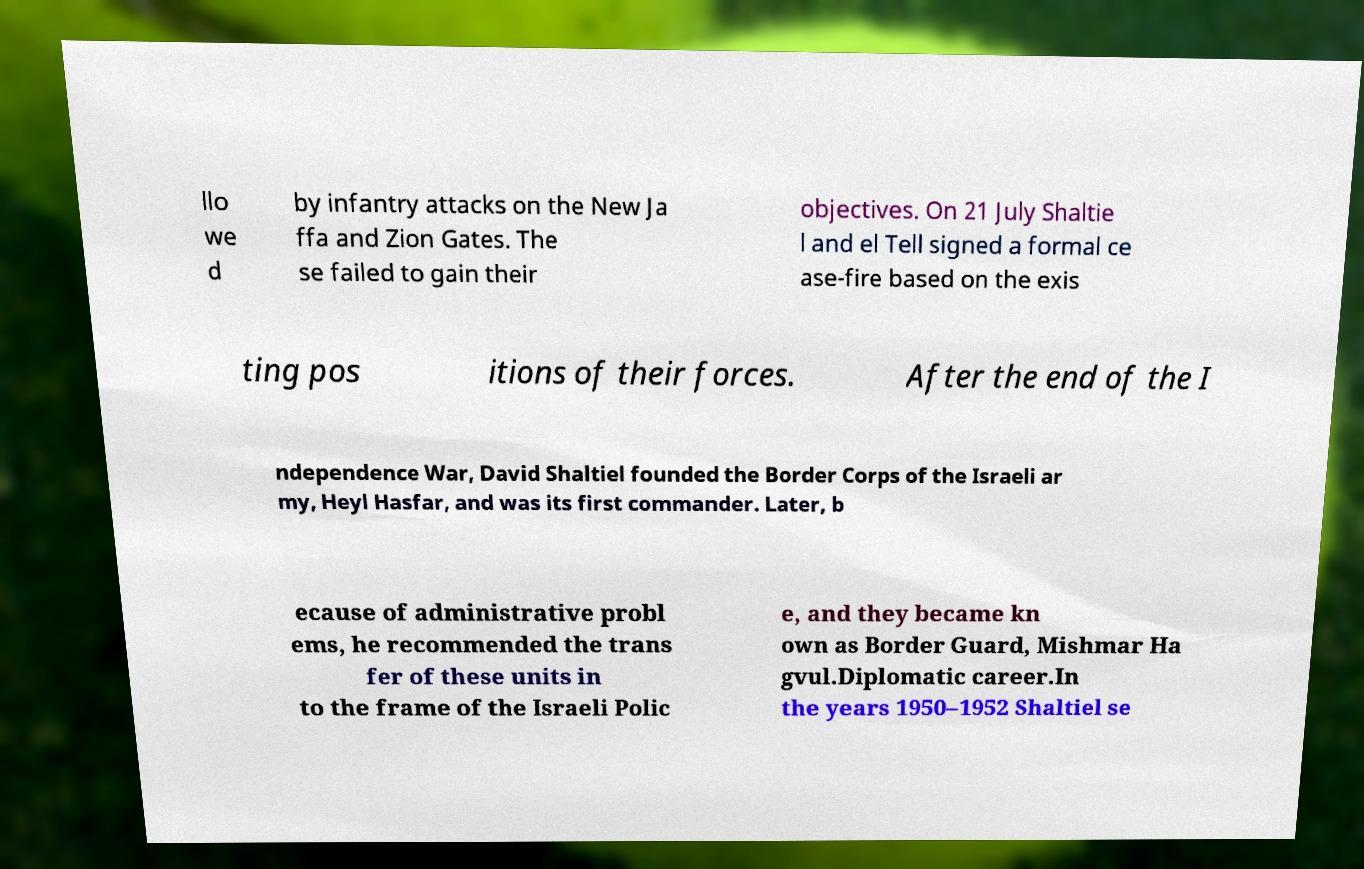Can you accurately transcribe the text from the provided image for me? llo we d by infantry attacks on the New Ja ffa and Zion Gates. The se failed to gain their objectives. On 21 July Shaltie l and el Tell signed a formal ce ase-fire based on the exis ting pos itions of their forces. After the end of the I ndependence War, David Shaltiel founded the Border Corps of the Israeli ar my, Heyl Hasfar, and was its first commander. Later, b ecause of administrative probl ems, he recommended the trans fer of these units in to the frame of the Israeli Polic e, and they became kn own as Border Guard, Mishmar Ha gvul.Diplomatic career.In the years 1950–1952 Shaltiel se 